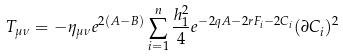Convert formula to latex. <formula><loc_0><loc_0><loc_500><loc_500>T _ { \mu \nu } = - \eta _ { \mu \nu } e ^ { 2 ( A - B ) } \sum _ { i = 1 } ^ { n } \frac { h _ { 1 } ^ { 2 } } { 4 } e ^ { - 2 q A - 2 r F _ { i } - 2 C _ { i } } ( \partial C _ { i } ) ^ { 2 }</formula> 